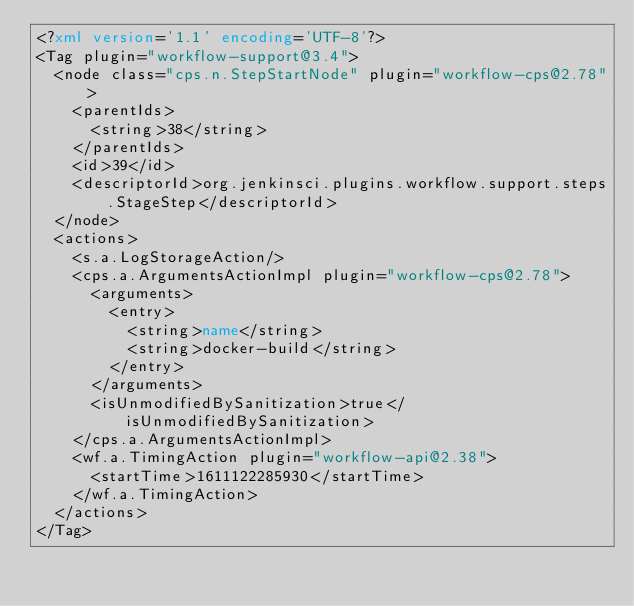Convert code to text. <code><loc_0><loc_0><loc_500><loc_500><_XML_><?xml version='1.1' encoding='UTF-8'?>
<Tag plugin="workflow-support@3.4">
  <node class="cps.n.StepStartNode" plugin="workflow-cps@2.78">
    <parentIds>
      <string>38</string>
    </parentIds>
    <id>39</id>
    <descriptorId>org.jenkinsci.plugins.workflow.support.steps.StageStep</descriptorId>
  </node>
  <actions>
    <s.a.LogStorageAction/>
    <cps.a.ArgumentsActionImpl plugin="workflow-cps@2.78">
      <arguments>
        <entry>
          <string>name</string>
          <string>docker-build</string>
        </entry>
      </arguments>
      <isUnmodifiedBySanitization>true</isUnmodifiedBySanitization>
    </cps.a.ArgumentsActionImpl>
    <wf.a.TimingAction plugin="workflow-api@2.38">
      <startTime>1611122285930</startTime>
    </wf.a.TimingAction>
  </actions>
</Tag></code> 